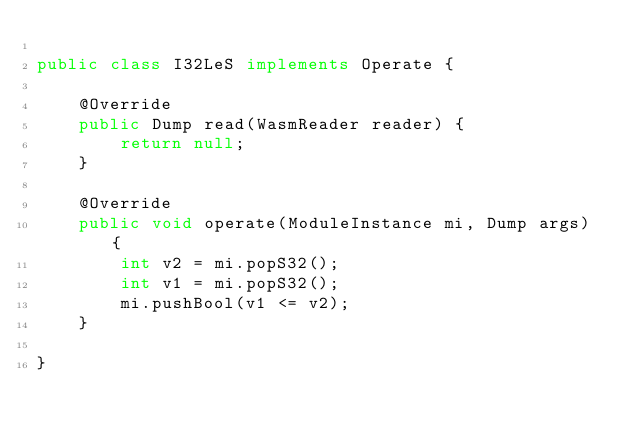<code> <loc_0><loc_0><loc_500><loc_500><_Java_>
public class I32LeS implements Operate {

    @Override
    public Dump read(WasmReader reader) {
        return null;
    }

    @Override
    public void operate(ModuleInstance mi, Dump args) {
        int v2 = mi.popS32();
        int v1 = mi.popS32();
        mi.pushBool(v1 <= v2);
    }

}
</code> 